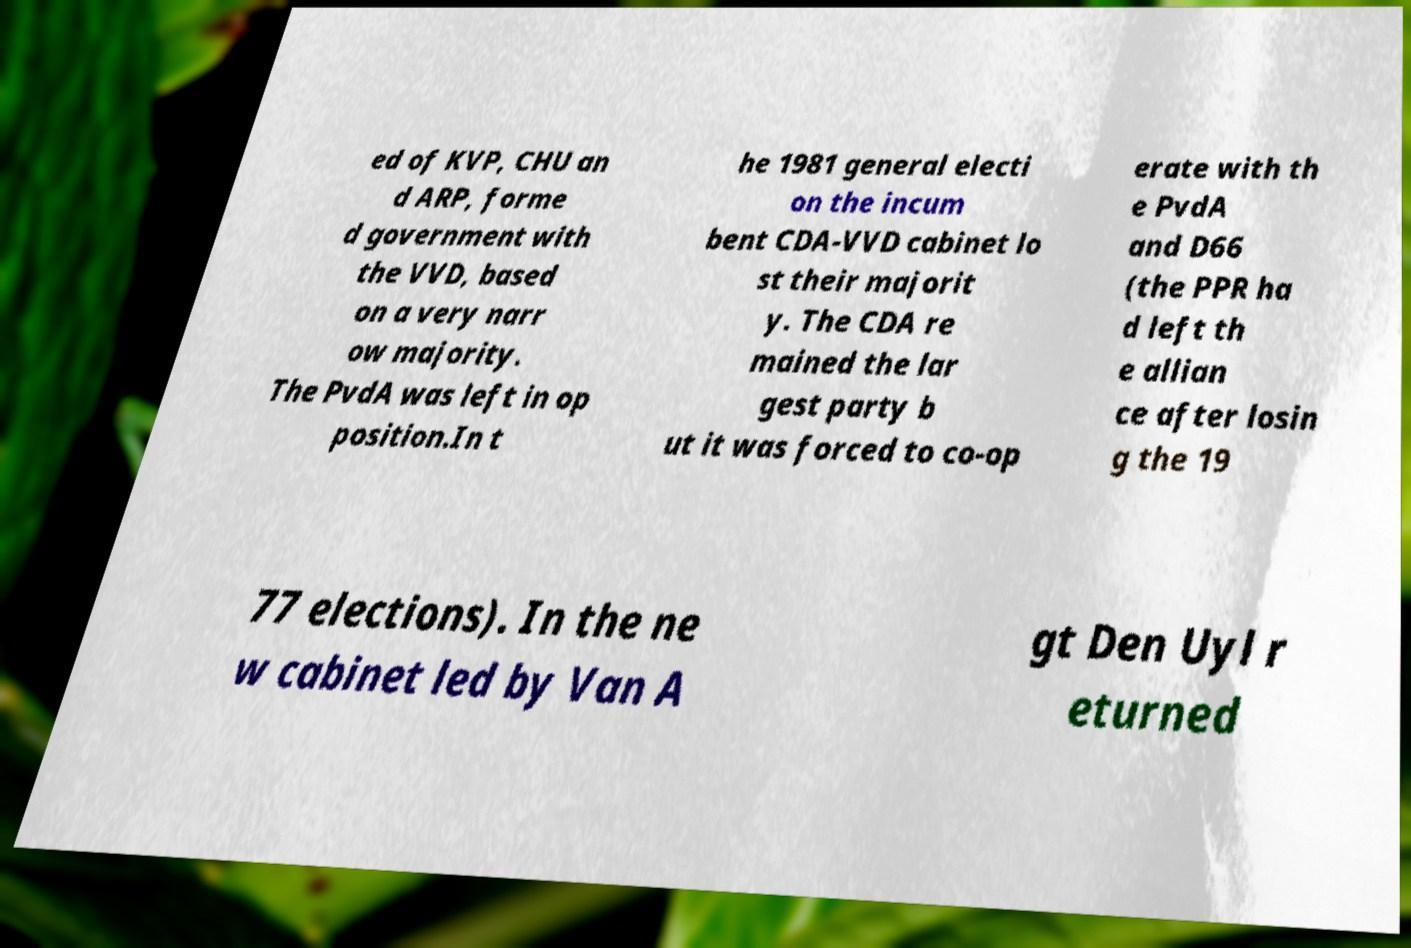Could you assist in decoding the text presented in this image and type it out clearly? ed of KVP, CHU an d ARP, forme d government with the VVD, based on a very narr ow majority. The PvdA was left in op position.In t he 1981 general electi on the incum bent CDA-VVD cabinet lo st their majorit y. The CDA re mained the lar gest party b ut it was forced to co-op erate with th e PvdA and D66 (the PPR ha d left th e allian ce after losin g the 19 77 elections). In the ne w cabinet led by Van A gt Den Uyl r eturned 